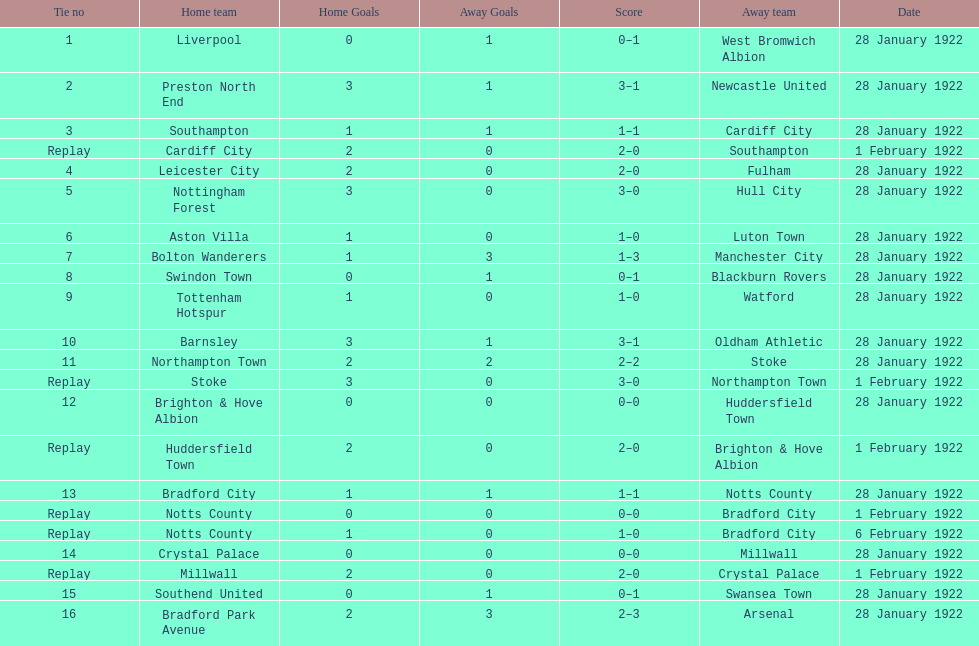What date did they play before feb 1? 28 January 1922. 